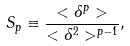Convert formula to latex. <formula><loc_0><loc_0><loc_500><loc_500>S _ { p } \equiv \frac { < \delta ^ { p } > } { < \delta ^ { 2 } > ^ { p - 1 } } ,</formula> 